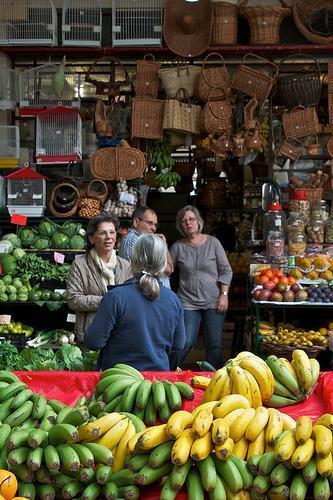How many women are here?
Give a very brief answer. 3. 